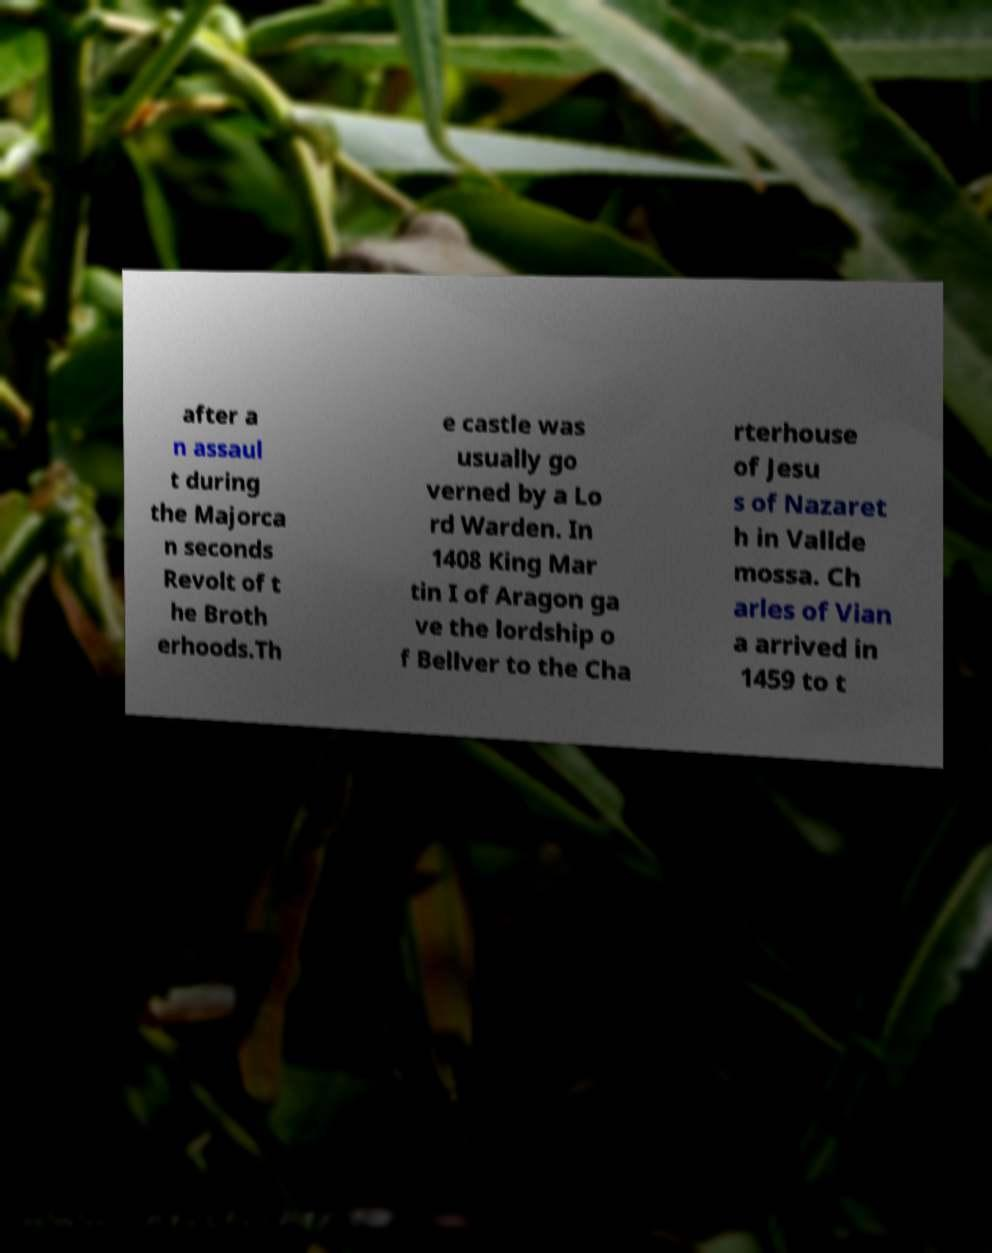What messages or text are displayed in this image? I need them in a readable, typed format. after a n assaul t during the Majorca n seconds Revolt of t he Broth erhoods.Th e castle was usually go verned by a Lo rd Warden. In 1408 King Mar tin I of Aragon ga ve the lordship o f Bellver to the Cha rterhouse of Jesu s of Nazaret h in Vallde mossa. Ch arles of Vian a arrived in 1459 to t 